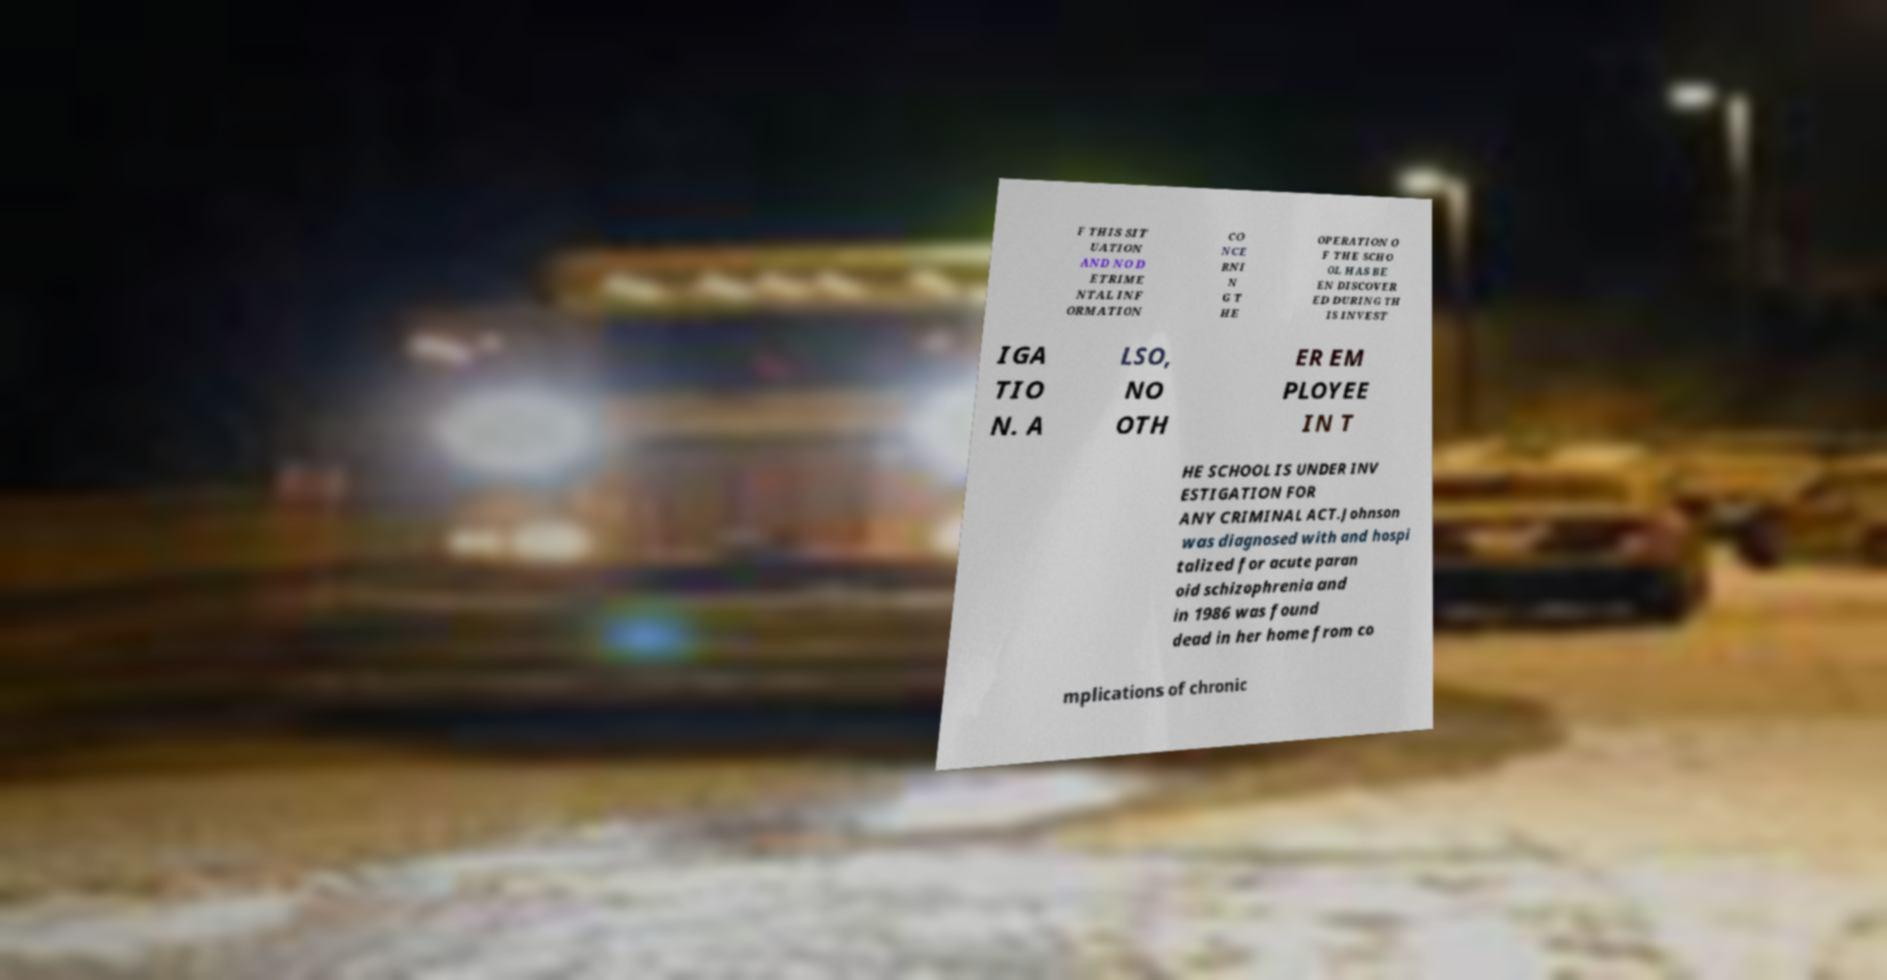There's text embedded in this image that I need extracted. Can you transcribe it verbatim? F THIS SIT UATION AND NO D ETRIME NTAL INF ORMATION CO NCE RNI N G T HE OPERATION O F THE SCHO OL HAS BE EN DISCOVER ED DURING TH IS INVEST IGA TIO N. A LSO, NO OTH ER EM PLOYEE IN T HE SCHOOL IS UNDER INV ESTIGATION FOR ANY CRIMINAL ACT.Johnson was diagnosed with and hospi talized for acute paran oid schizophrenia and in 1986 was found dead in her home from co mplications of chronic 